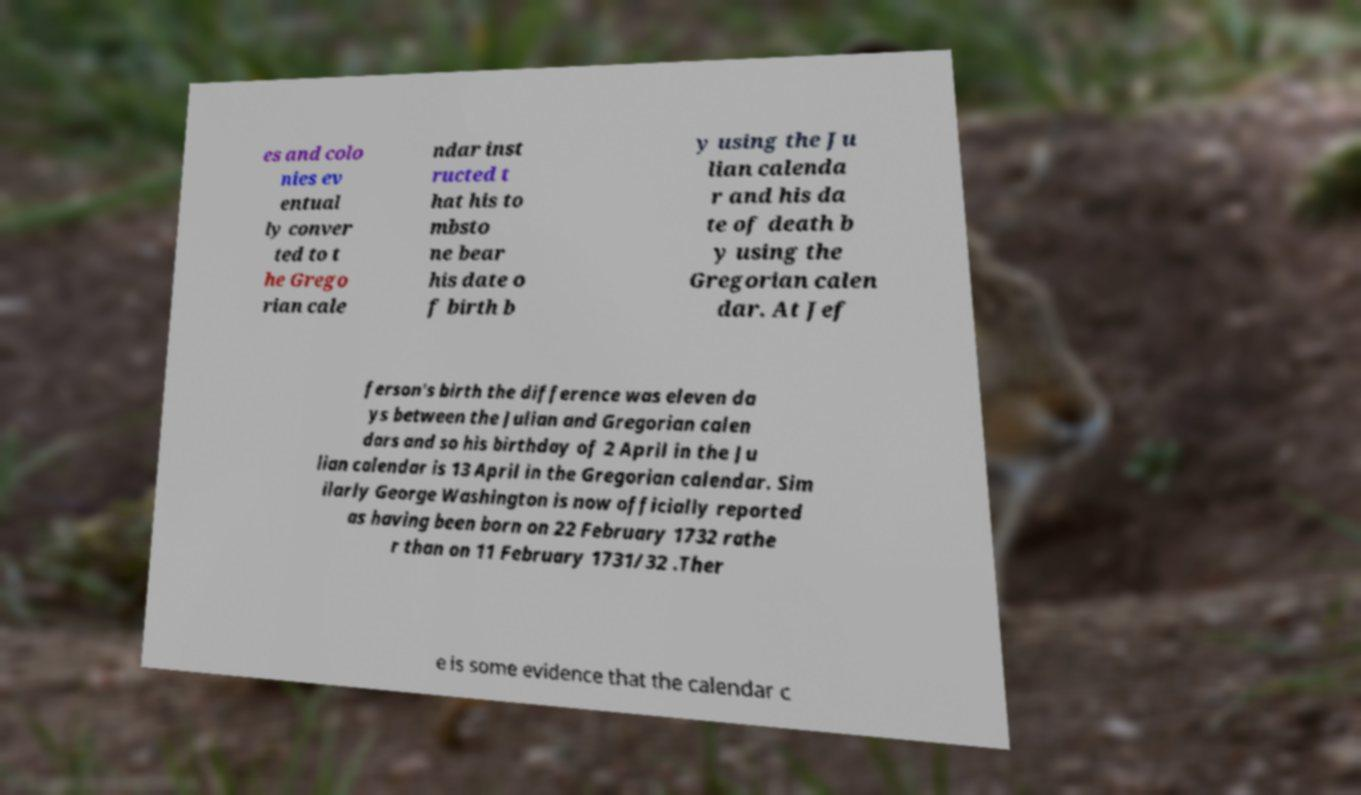I need the written content from this picture converted into text. Can you do that? es and colo nies ev entual ly conver ted to t he Grego rian cale ndar inst ructed t hat his to mbsto ne bear his date o f birth b y using the Ju lian calenda r and his da te of death b y using the Gregorian calen dar. At Jef ferson's birth the difference was eleven da ys between the Julian and Gregorian calen dars and so his birthday of 2 April in the Ju lian calendar is 13 April in the Gregorian calendar. Sim ilarly George Washington is now officially reported as having been born on 22 February 1732 rathe r than on 11 February 1731/32 .Ther e is some evidence that the calendar c 